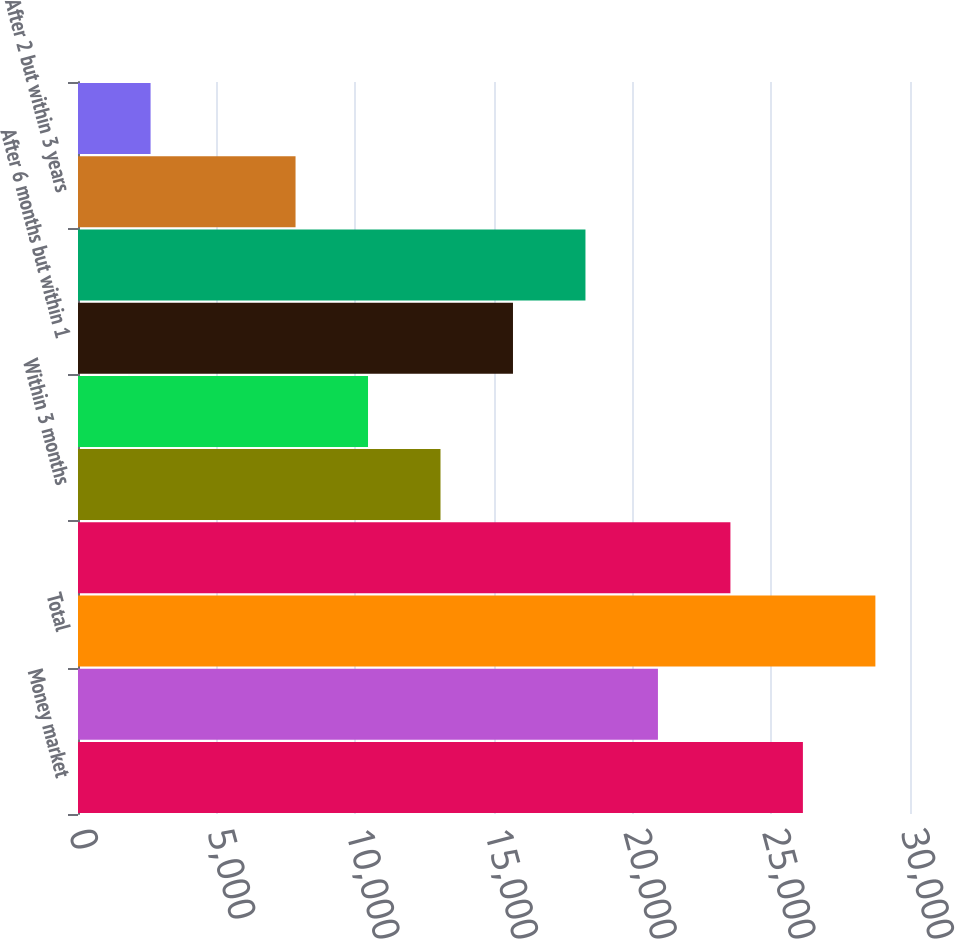Convert chart. <chart><loc_0><loc_0><loc_500><loc_500><bar_chart><fcel>Money market<fcel>Interest-bearing checking<fcel>Total<fcel>Savings<fcel>Within 3 months<fcel>After 3 but within 6 months<fcel>After 6 months but within 1<fcel>After 1 but within 2 years<fcel>After 2 but within 3 years<fcel>After 3 but within 4 years<nl><fcel>26138.2<fcel>20911.3<fcel>28751.7<fcel>23524.7<fcel>13070.9<fcel>10457.4<fcel>15684.4<fcel>18297.8<fcel>7843.98<fcel>2617.06<nl></chart> 